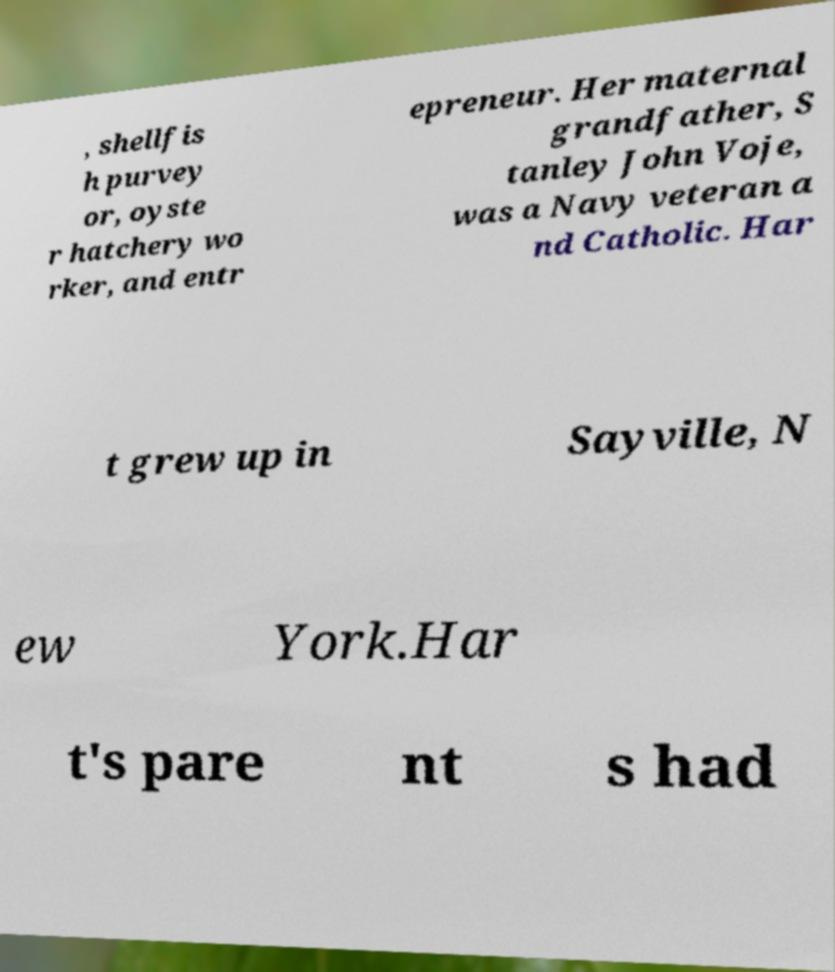Please identify and transcribe the text found in this image. , shellfis h purvey or, oyste r hatchery wo rker, and entr epreneur. Her maternal grandfather, S tanley John Voje, was a Navy veteran a nd Catholic. Har t grew up in Sayville, N ew York.Har t's pare nt s had 